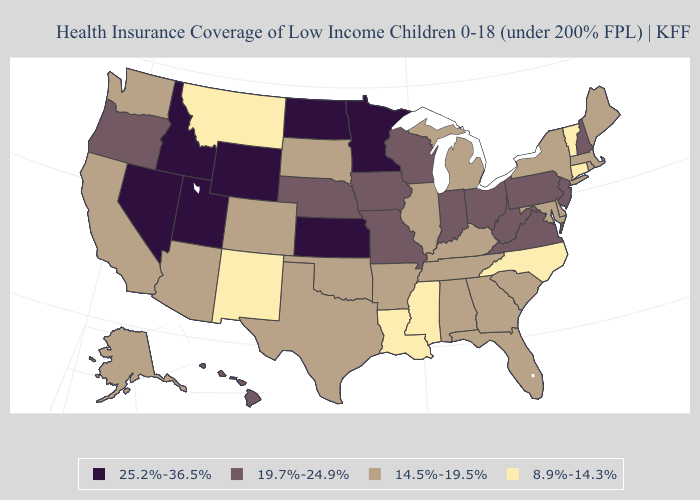Does Alaska have the lowest value in the West?
Give a very brief answer. No. Name the states that have a value in the range 14.5%-19.5%?
Be succinct. Alabama, Alaska, Arizona, Arkansas, California, Colorado, Delaware, Florida, Georgia, Illinois, Kentucky, Maine, Maryland, Massachusetts, Michigan, New York, Oklahoma, Rhode Island, South Carolina, South Dakota, Tennessee, Texas, Washington. What is the value of Alaska?
Concise answer only. 14.5%-19.5%. What is the highest value in states that border Iowa?
Answer briefly. 25.2%-36.5%. What is the value of Minnesota?
Be succinct. 25.2%-36.5%. What is the highest value in states that border Missouri?
Give a very brief answer. 25.2%-36.5%. What is the value of Nebraska?
Answer briefly. 19.7%-24.9%. How many symbols are there in the legend?
Answer briefly. 4. Name the states that have a value in the range 25.2%-36.5%?
Quick response, please. Idaho, Kansas, Minnesota, Nevada, North Dakota, Utah, Wyoming. Does Montana have the lowest value in the USA?
Write a very short answer. Yes. Does Texas have the lowest value in the South?
Quick response, please. No. Does North Carolina have a higher value than Mississippi?
Quick response, please. No. Does the map have missing data?
Keep it brief. No. How many symbols are there in the legend?
Short answer required. 4. Name the states that have a value in the range 8.9%-14.3%?
Short answer required. Connecticut, Louisiana, Mississippi, Montana, New Mexico, North Carolina, Vermont. 